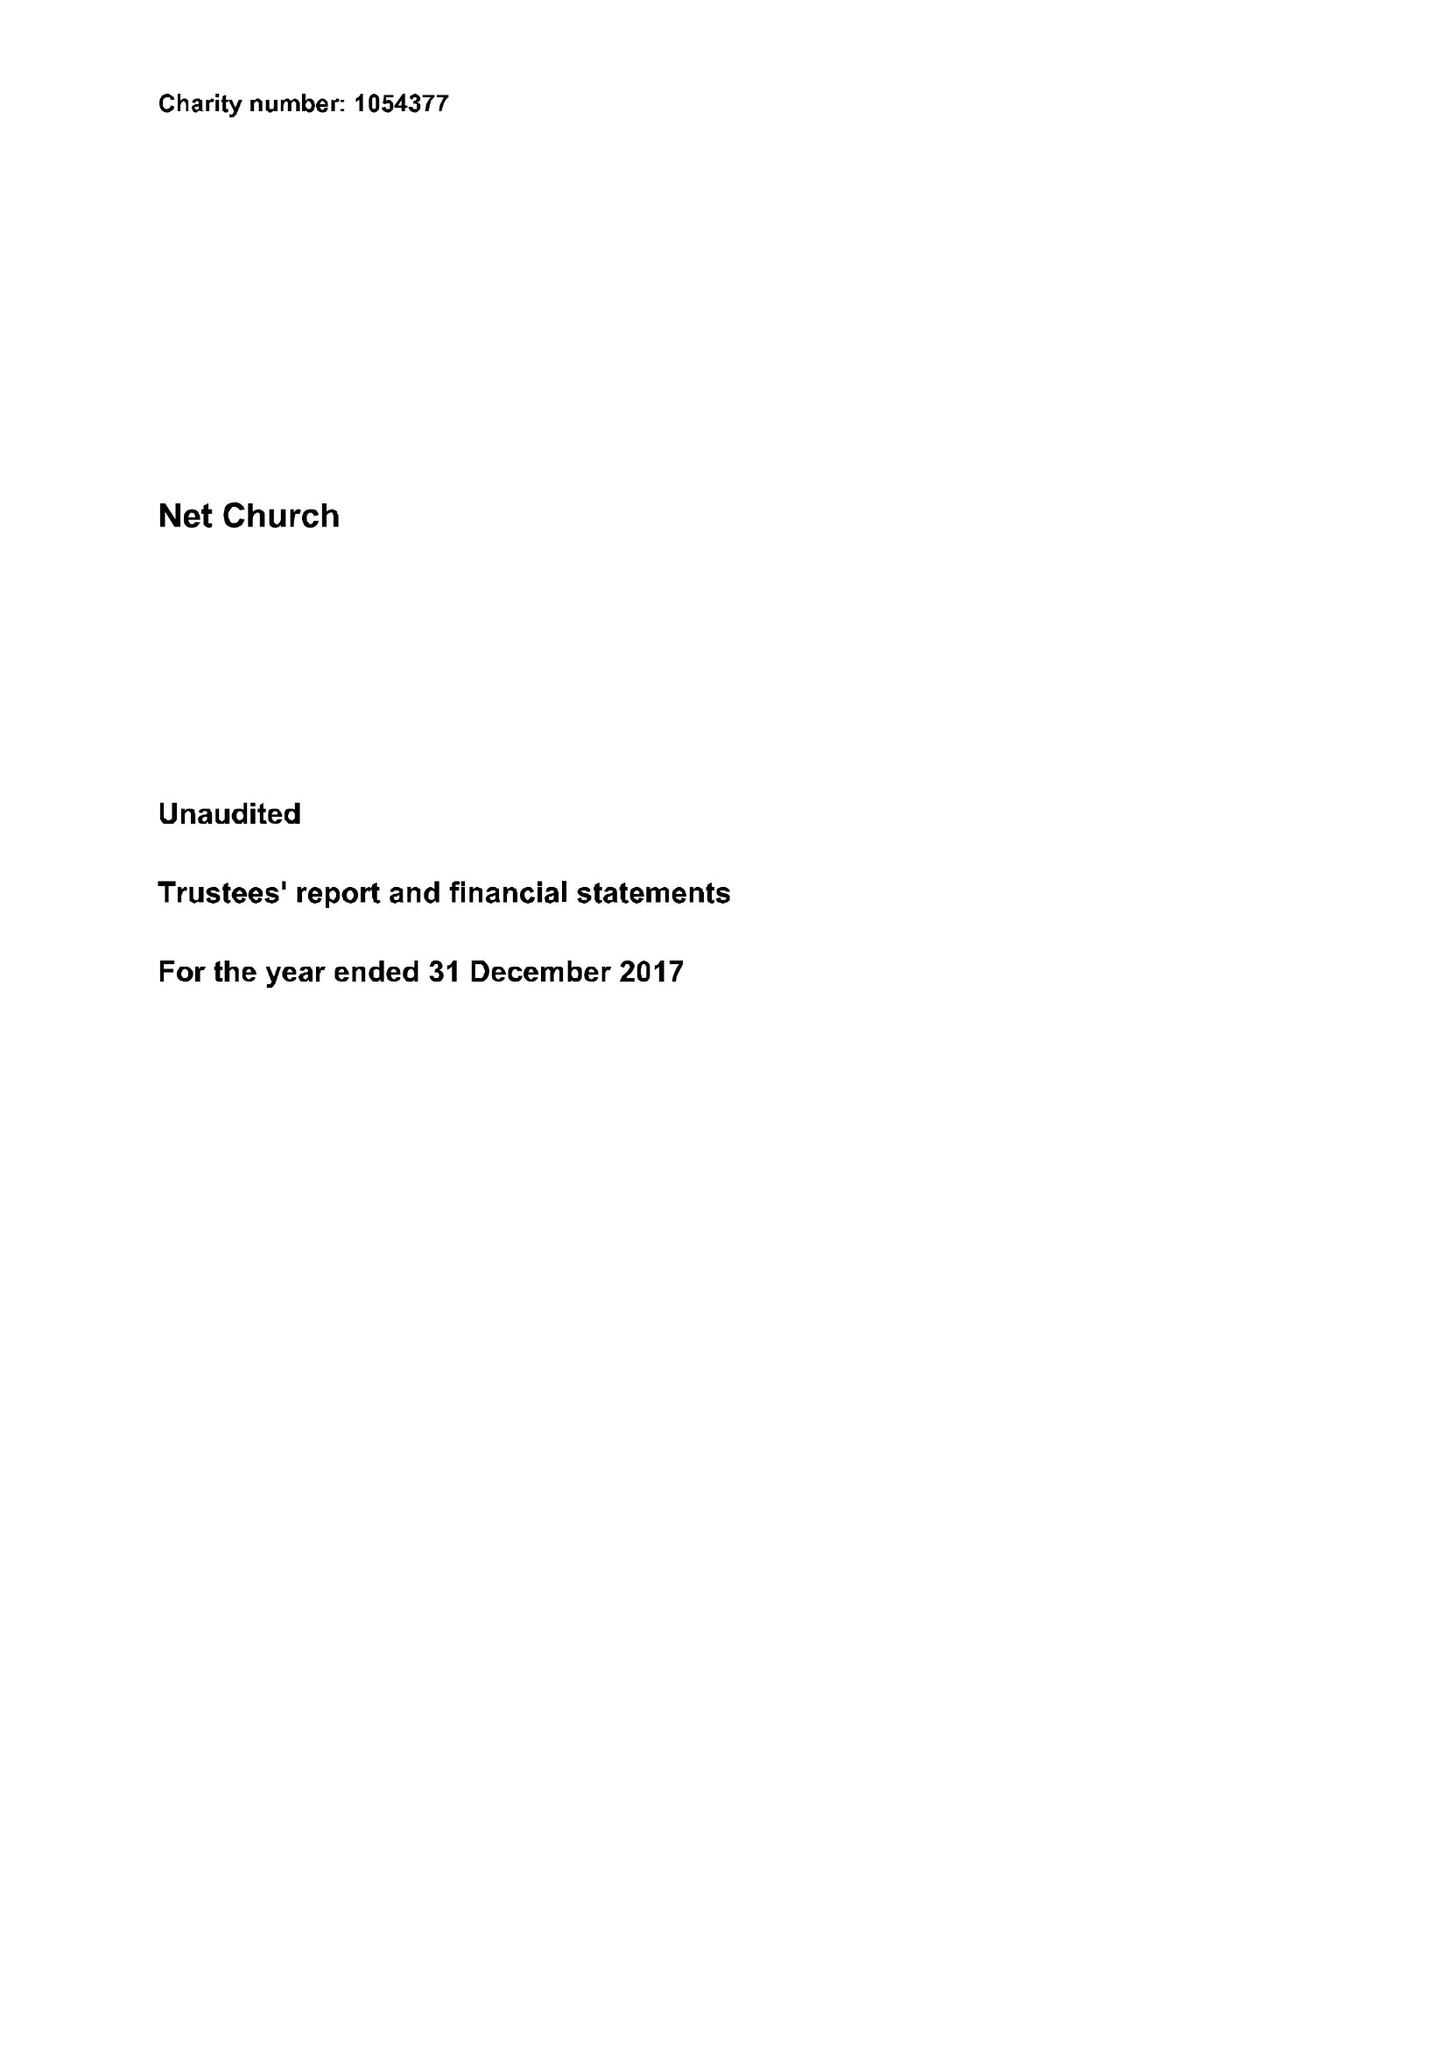What is the value for the address__postcode?
Answer the question using a single word or phrase. ME10 4BL 